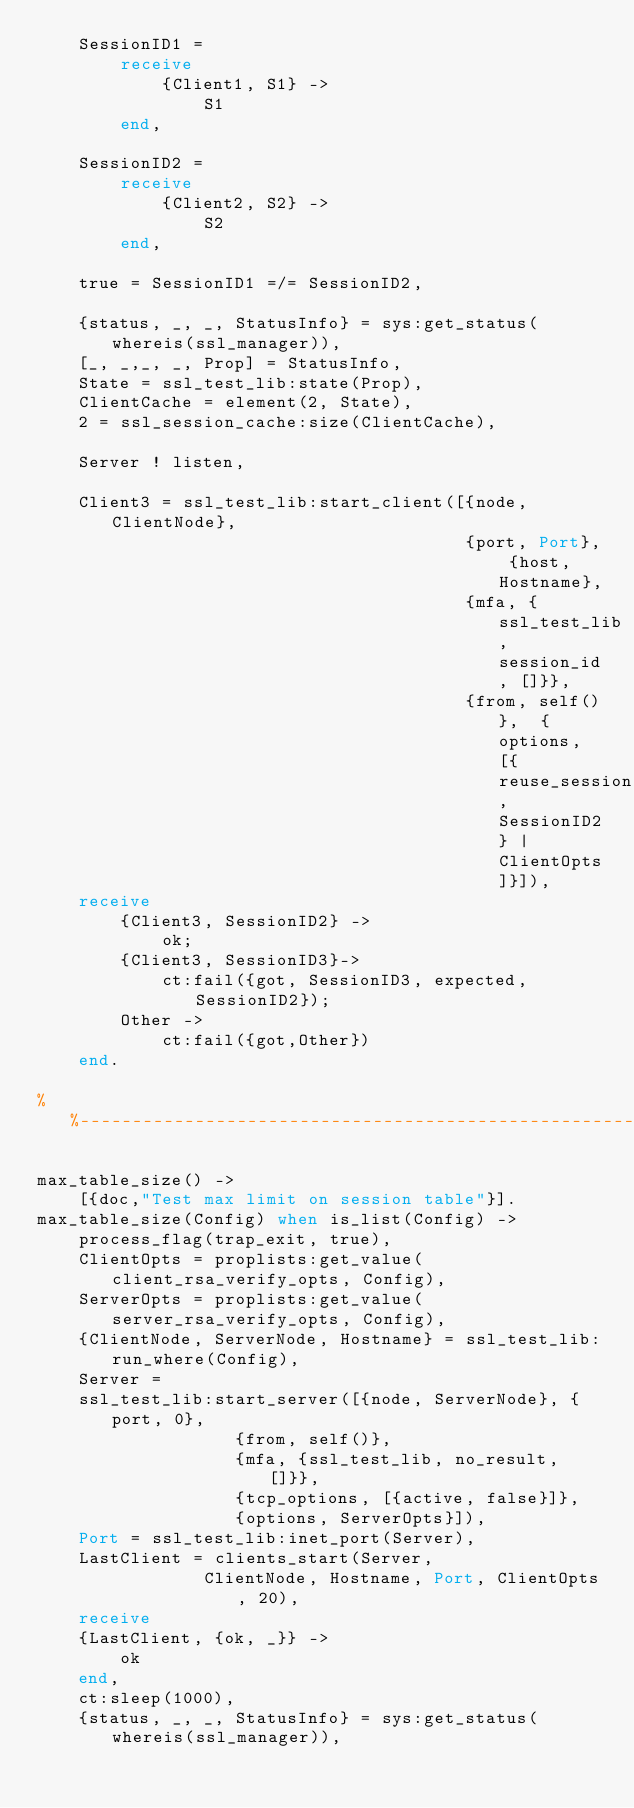Convert code to text. <code><loc_0><loc_0><loc_500><loc_500><_Erlang_>    SessionID1 =
        receive 
            {Client1, S1} ->
                S1
        end,
    
    SessionID2 =
        receive 
            {Client2, S2} ->
                S2
        end,
    
    true = SessionID1 =/= SessionID2,

    {status, _, _, StatusInfo} = sys:get_status(whereis(ssl_manager)),
    [_, _,_, _, Prop] = StatusInfo,
    State = ssl_test_lib:state(Prop),
    ClientCache = element(2, State),
    2 = ssl_session_cache:size(ClientCache),

    Server ! listen,

    Client3 = ssl_test_lib:start_client([{node, ClientNode},
                                         {port, Port}, {host, Hostname},
                                         {mfa, {ssl_test_lib, session_id, []}},
                                         {from, self()},  {options, [{reuse_session, SessionID2} | ClientOpts]}]), 
    receive 
        {Client3, SessionID2} ->
            ok;
        {Client3, SessionID3}->
            ct:fail({got, SessionID3, expected, SessionID2});
        Other ->
            ct:fail({got,Other})
    end.

%%--------------------------------------------------------------------

max_table_size() ->
    [{doc,"Test max limit on session table"}].
max_table_size(Config) when is_list(Config) ->
    process_flag(trap_exit, true),
    ClientOpts = proplists:get_value(client_rsa_verify_opts, Config),
    ServerOpts = proplists:get_value(server_rsa_verify_opts, Config),
    {ClientNode, ServerNode, Hostname} = ssl_test_lib:run_where(Config),
    Server =
	ssl_test_lib:start_server([{node, ServerNode}, {port, 0},
				   {from, self()},
				   {mfa, {ssl_test_lib, no_result, []}},
				   {tcp_options, [{active, false}]},
				   {options, ServerOpts}]),
    Port = ssl_test_lib:inet_port(Server),
    LastClient = clients_start(Server, 
			    ClientNode, Hostname, Port, ClientOpts, 20),
    receive 
	{LastClient, {ok, _}} ->
	    ok
    end,
    ct:sleep(1000),
    {status, _, _, StatusInfo} = sys:get_status(whereis(ssl_manager)),</code> 